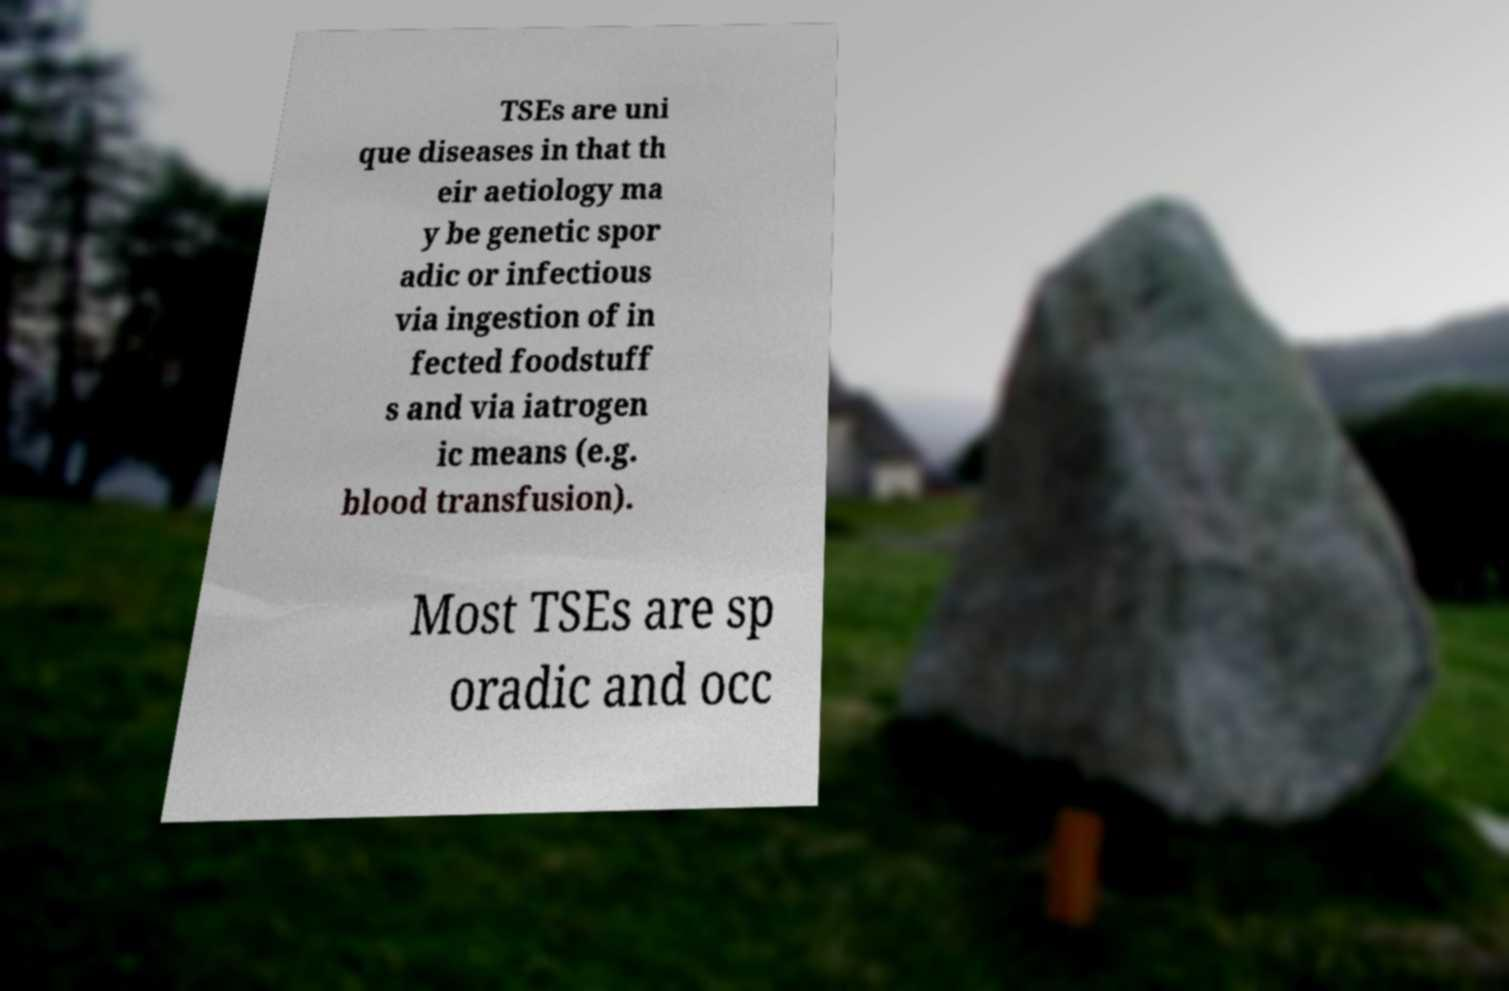Could you extract and type out the text from this image? TSEs are uni que diseases in that th eir aetiology ma y be genetic spor adic or infectious via ingestion of in fected foodstuff s and via iatrogen ic means (e.g. blood transfusion). Most TSEs are sp oradic and occ 